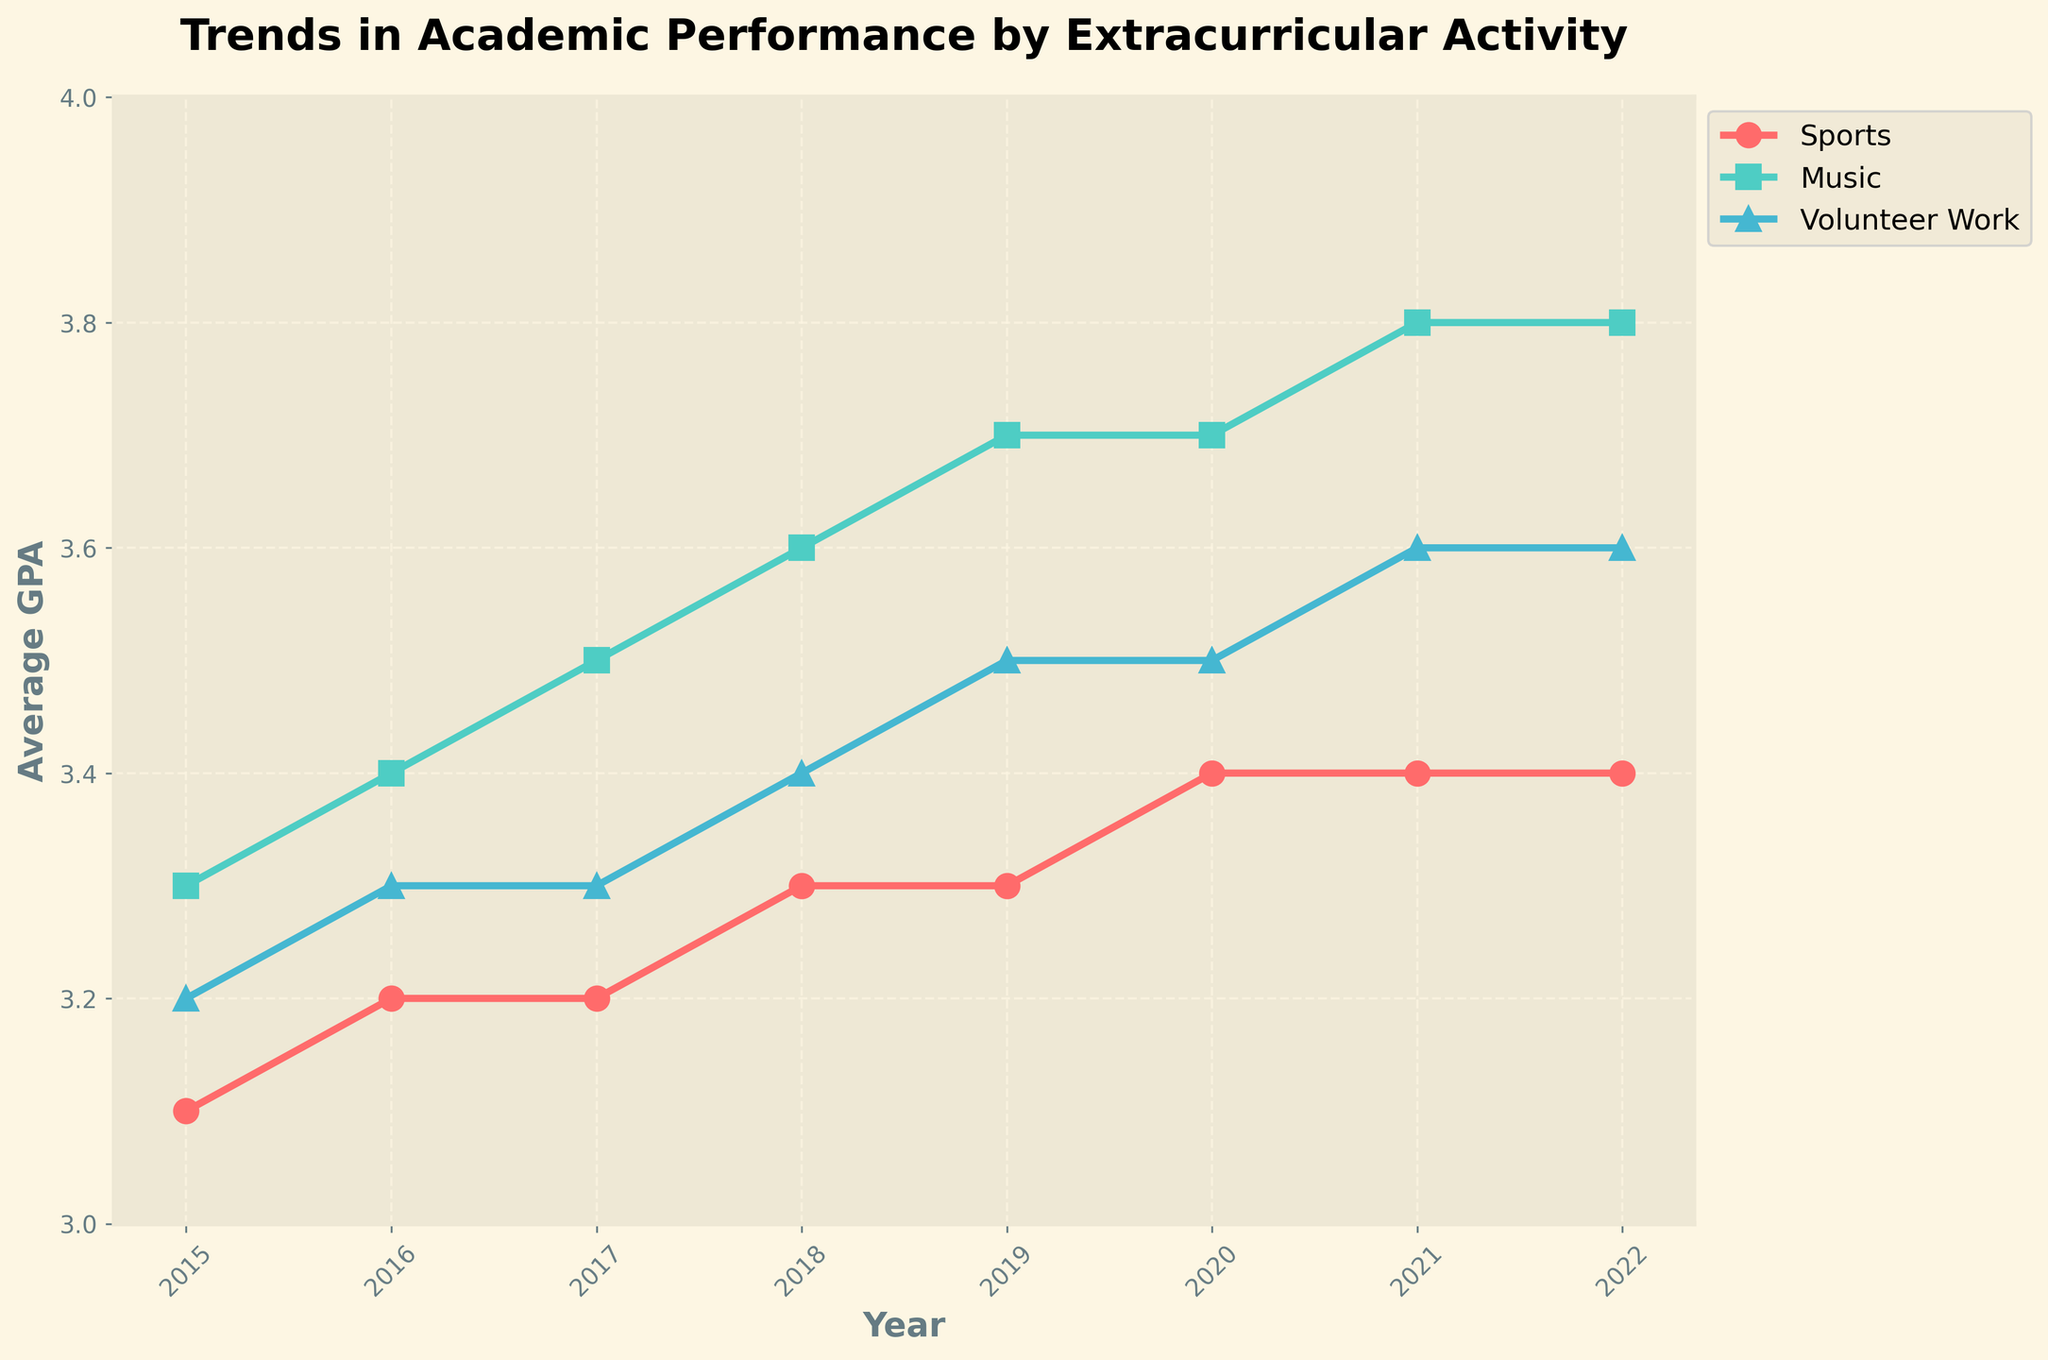What's the title of the figure? The title is located at the top of the figure. It helps the viewer understand what the data is about. From the prompt, we know that the title is "Trends in Academic Performance by Extracurricular Activity".
Answer: Trends in Academic Performance by Extracurricular Activity What's the highest average GPA among all activities in the year 2022? Look at the data points for the year 2022 across all activities. The highest average GPA is for Music at 3.8.
Answer: 3.8 How does the average GPA for Sports change from 2015 to 2022? Check the average GPA for Sports in 2015 and compare it with 2022. It changes from 3.1 in 2015 to 3.4 in 2022.
Answer: Increased by 0.3 Which extracurricular activity has consistently shown an upward trend in GPA from 2015 to 2022? Analyze the trend lines of all activities from 2015 to 2022. Music consistently shows an upward trend in GPA, increasing every year.
Answer: Music What was the difference in average GPA between Music and Sports in 2021? Note the GPAs for Music and Sports in 2021, which are 3.8 and 3.4 respectively. The difference is calculated by 3.8 - 3.4.
Answer: 0.4 Which year showed the highest increase in average GPA for Volunteer Work compared to the previous year? Examine the year-over-year changes in GPA for Volunteer Work. From 2017 to 2018, the GPA increased from 3.3 to 3.4, the highest increase of 0.1.
Answer: 2018 How many unique years are plotted in the figure? Count the unique points on the x-axis representing the years. There are 8 unique years from 2015 to 2022.
Answer: 8 Is there any extracurricular activity for which the average GPA remained constant at any point? Check each activity's trend line. The average GPA for Sports remains constant between 2019 to 2021 (same value of 3.4).
Answer: Yes, Sports Compare the average GPA for Volunteer Work in 2018 to that in 2015. Is there any improvement? Volunteer Work's GPA in 2018 is 3.4 while in 2015 it was 3.2. This shows an improvement by 0.2.
Answer: Yes Which activity had the highest average GPA in 2017? Check the different activities' trend lines and find the highest GPA for the year 2017, which is Music at 3.5.
Answer: Music 